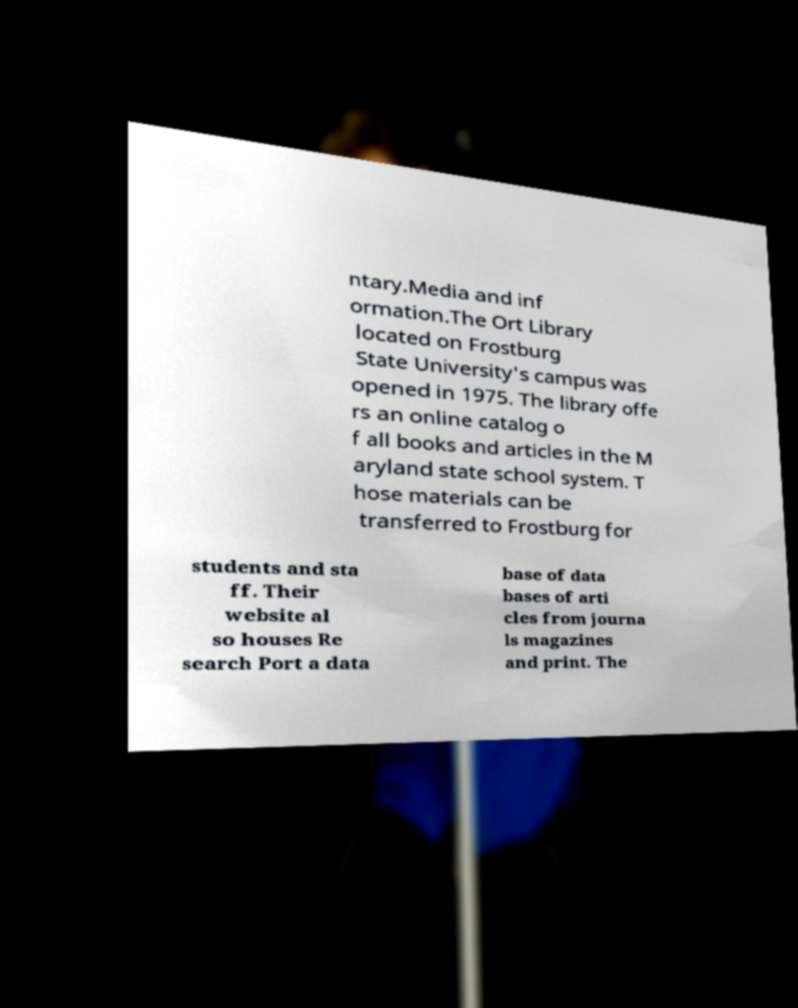For documentation purposes, I need the text within this image transcribed. Could you provide that? ntary.Media and inf ormation.The Ort Library located on Frostburg State University's campus was opened in 1975. The library offe rs an online catalog o f all books and articles in the M aryland state school system. T hose materials can be transferred to Frostburg for students and sta ff. Their website al so houses Re search Port a data base of data bases of arti cles from journa ls magazines and print. The 